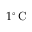<formula> <loc_0><loc_0><loc_500><loc_500>1 ^ { \circ } \, C</formula> 